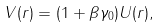Convert formula to latex. <formula><loc_0><loc_0><loc_500><loc_500>V ( r ) = ( 1 + \beta \gamma _ { 0 } ) U ( r ) ,</formula> 